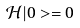<formula> <loc_0><loc_0><loc_500><loc_500>\mathcal { H } | 0 > = 0</formula> 